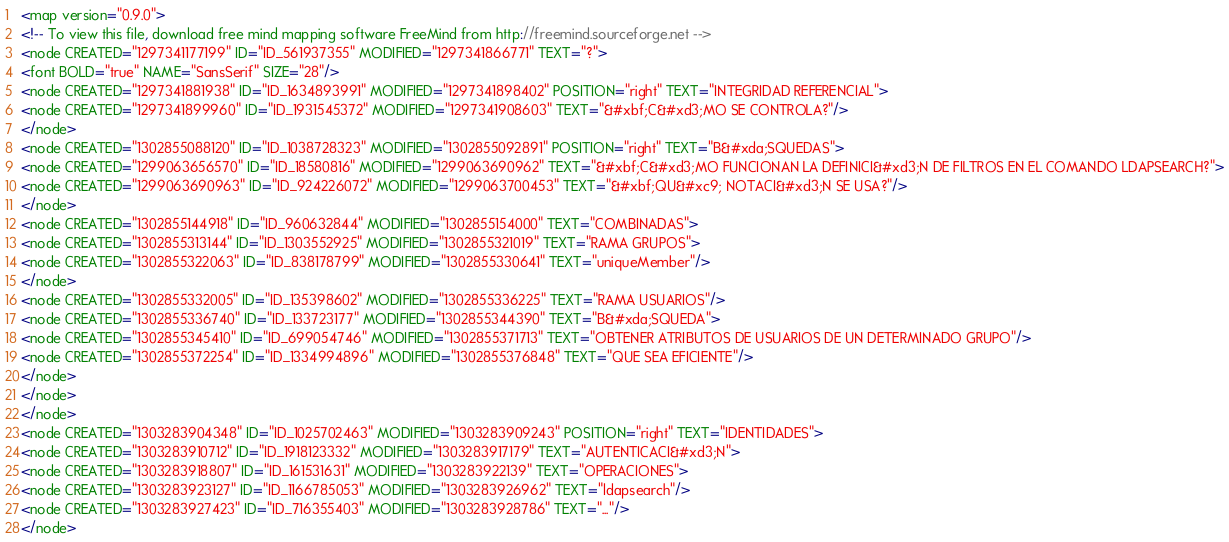<code> <loc_0><loc_0><loc_500><loc_500><_ObjectiveC_><map version="0.9.0">
<!-- To view this file, download free mind mapping software FreeMind from http://freemind.sourceforge.net -->
<node CREATED="1297341177199" ID="ID_561937355" MODIFIED="1297341866771" TEXT="?">
<font BOLD="true" NAME="SansSerif" SIZE="28"/>
<node CREATED="1297341881938" ID="ID_1634893991" MODIFIED="1297341898402" POSITION="right" TEXT="INTEGRIDAD REFERENCIAL">
<node CREATED="1297341899960" ID="ID_1931545372" MODIFIED="1297341908603" TEXT="&#xbf;C&#xd3;MO SE CONTROLA?"/>
</node>
<node CREATED="1302855088120" ID="ID_1038728323" MODIFIED="1302855092891" POSITION="right" TEXT="B&#xda;SQUEDAS">
<node CREATED="1299063656570" ID="ID_18580816" MODIFIED="1299063690962" TEXT="&#xbf;C&#xd3;MO FUNCIONAN LA DEFINICI&#xd3;N DE FILTROS EN EL COMANDO LDAPSEARCH?">
<node CREATED="1299063690963" ID="ID_924226072" MODIFIED="1299063700453" TEXT="&#xbf;QU&#xc9; NOTACI&#xd3;N SE USA?"/>
</node>
<node CREATED="1302855144918" ID="ID_960632844" MODIFIED="1302855154000" TEXT="COMBINADAS">
<node CREATED="1302855313144" ID="ID_1303552925" MODIFIED="1302855321019" TEXT="RAMA GRUPOS">
<node CREATED="1302855322063" ID="ID_838178799" MODIFIED="1302855330641" TEXT="uniqueMember"/>
</node>
<node CREATED="1302855332005" ID="ID_135398602" MODIFIED="1302855336225" TEXT="RAMA USUARIOS"/>
<node CREATED="1302855336740" ID="ID_133723177" MODIFIED="1302855344390" TEXT="B&#xda;SQUEDA">
<node CREATED="1302855345410" ID="ID_699054746" MODIFIED="1302855371713" TEXT="OBTENER ATRIBUTOS DE USUARIOS DE UN DETERMINADO GRUPO"/>
<node CREATED="1302855372254" ID="ID_1334994896" MODIFIED="1302855376848" TEXT="QUE SEA EFICIENTE"/>
</node>
</node>
</node>
<node CREATED="1303283904348" ID="ID_1025702463" MODIFIED="1303283909243" POSITION="right" TEXT="IDENTIDADES">
<node CREATED="1303283910712" ID="ID_1918123332" MODIFIED="1303283917179" TEXT="AUTENTICACI&#xd3;N">
<node CREATED="1303283918807" ID="ID_161531631" MODIFIED="1303283922139" TEXT="OPERACIONES">
<node CREATED="1303283923127" ID="ID_1166785053" MODIFIED="1303283926962" TEXT="ldapsearch"/>
<node CREATED="1303283927423" ID="ID_716355403" MODIFIED="1303283928786" TEXT="..."/>
</node></code> 